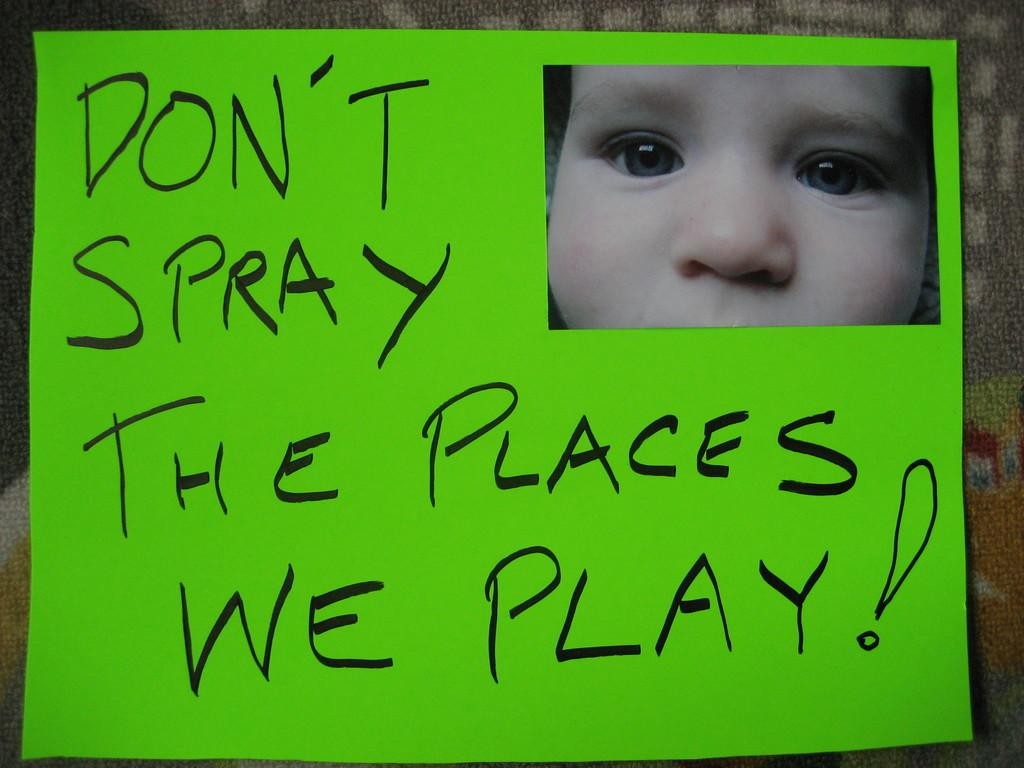What color is the paper in the image? The paper in the image is green. What is on the green paper? There is writing on the green paper. Is there any image on the green paper? Yes, there is a picture of a kid's face at the top of the green paper. What type of pan is being used in the competition depicted in the image? There is no competition or pan present in the image; it only contains a green paper with writing and a picture of a kid's face. 